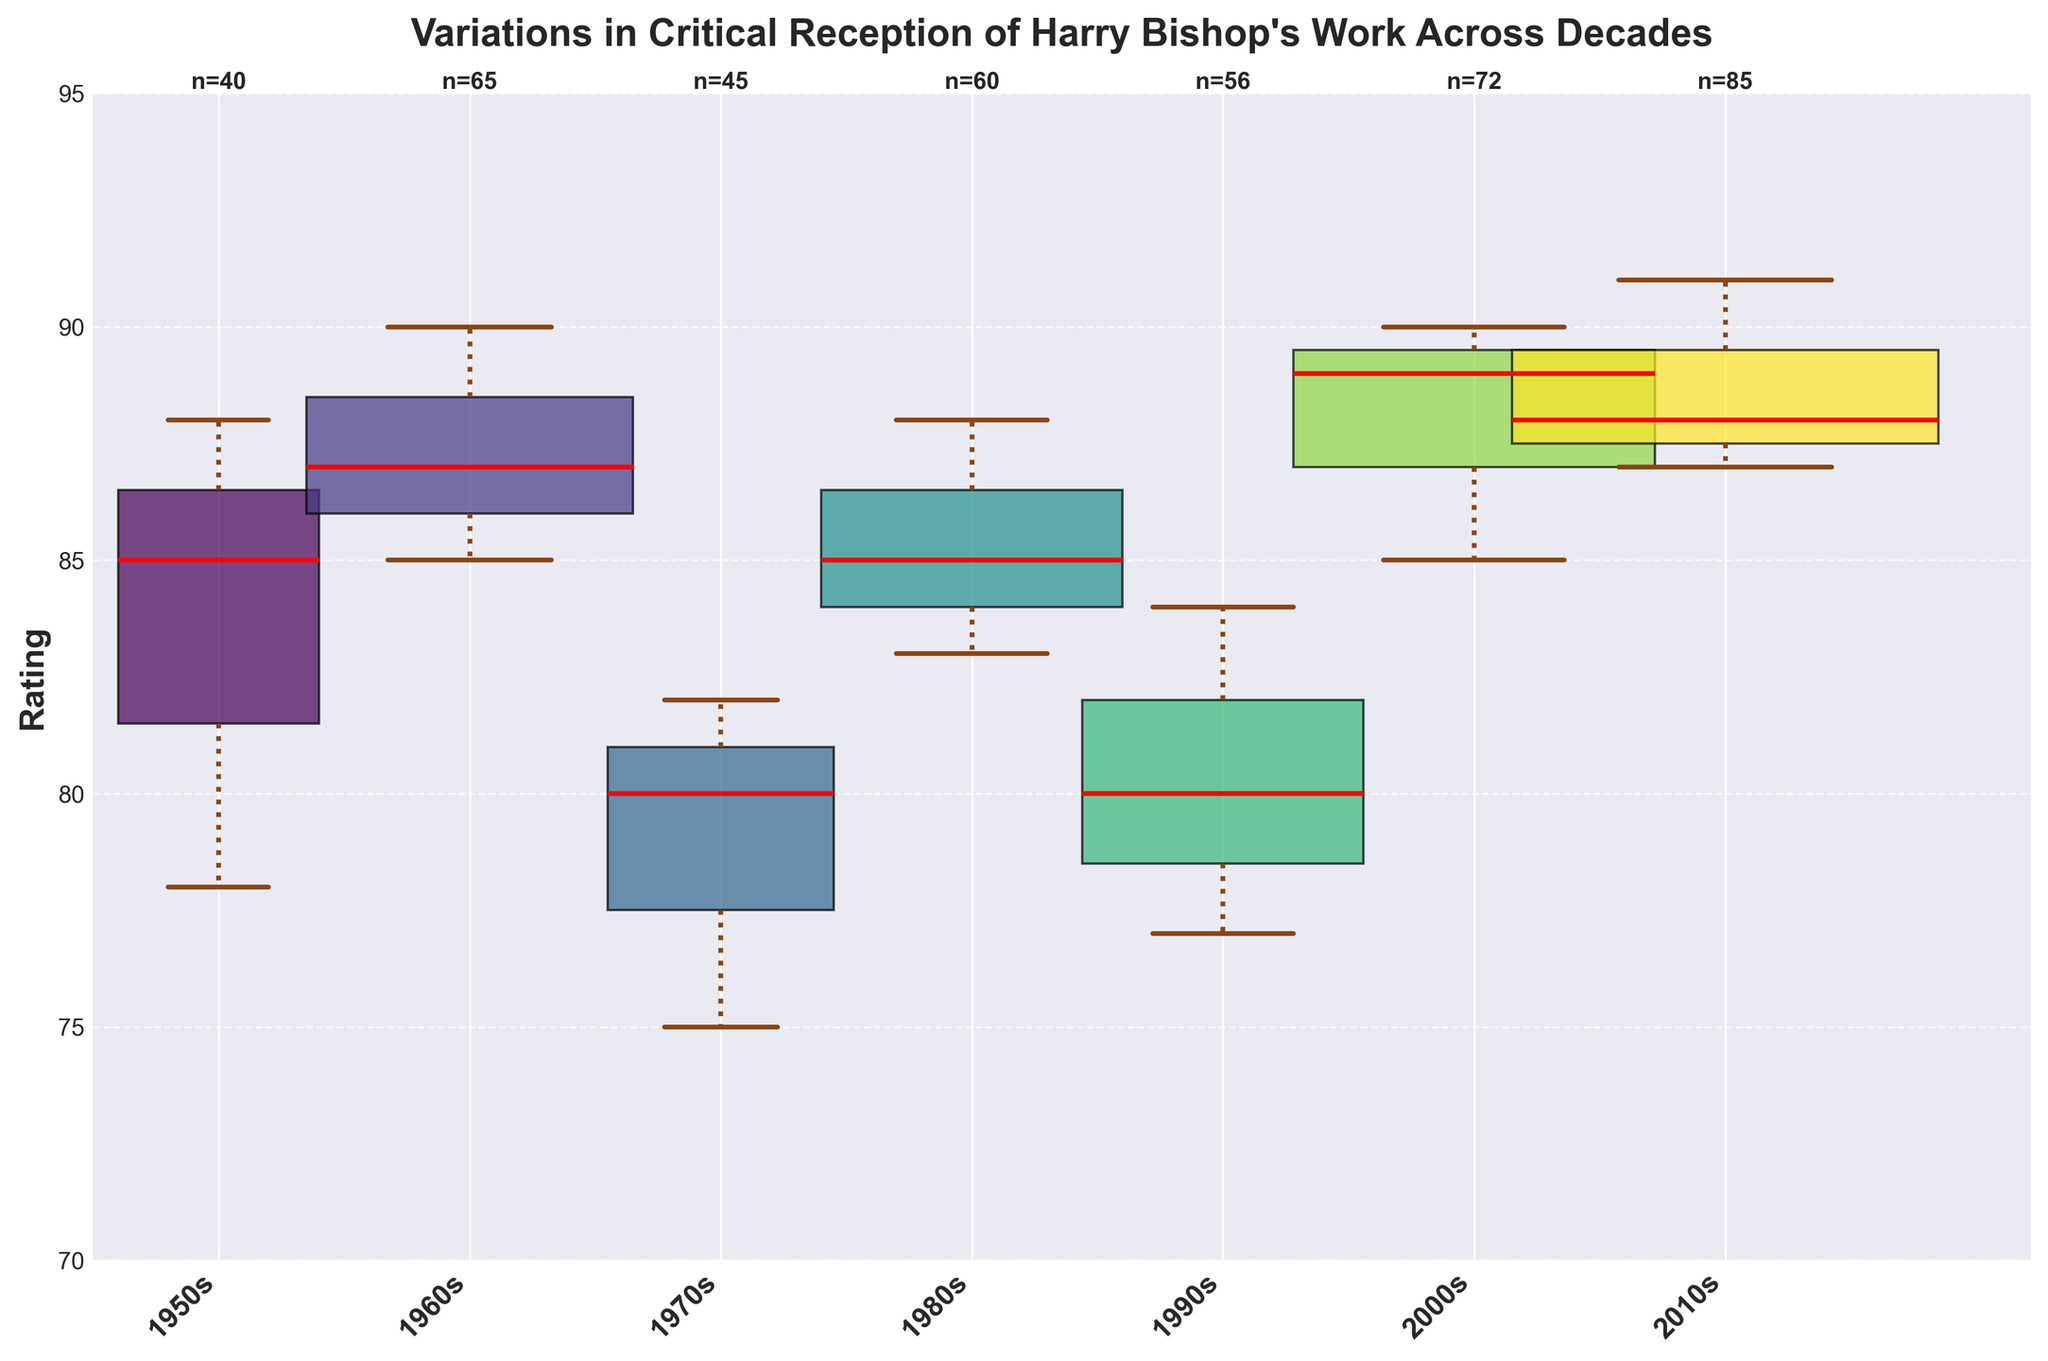What is the title of the plot? The title is typically found at the top center of the plot and clearly states what the plot is about. In this plot, it should be easily identifiable.
Answer: Variations in Critical Reception of Harry Bishop's Work Across Decades Which decade has the widest box? To determine this, look at the widths of the boxes in the plot, which correspond to the frequency data of ratings.
Answer: 2010s What is the median rating for the 1960s? Check the red line inside the box for the 1960s section. The median is where the line is located within the box.
Answer: 87 Which decade shows the highest variability in ratings? Assess which box plot has the largest interquartile range (IQR), i.e., the greatest distance between the top and bottom of the box.
Answer: 2000s How many total ratings were provided in the 1970s? Identify the annotation on the x-axis for the 1970s, which states the total frequency of ratings for that decade.
Answer: 45 Which decade has the highest median rating? Look for the box plot with the highest red line, which represents the median rating.
Answer: 2010s Compare the median ratings of the 1950s and 1980s. Which decade had the higher median rating? Check the red lines in the box plots for both decades and compare their vertical positions.
Answer: 1980s What is the interquartile range (IQR) for the 1980s? The IQR is the distance between the upper and lower quartiles of the box plot for the 1980s. Look at the top and bottom of the box to measure this range.
Answer: 5 (88-83) Which decade has the least number of total ratings, and how many? Find the decade with the smallest annotation on the x-axis, indicating the total frequency of ratings.
Answer: 1950s, 40 Are there any outliers in the ratings for the 1970s? Look for any data points marked with different shapes (e.g., diamonds) outside the whiskers of the box plot for the 1970s.
Answer: No 